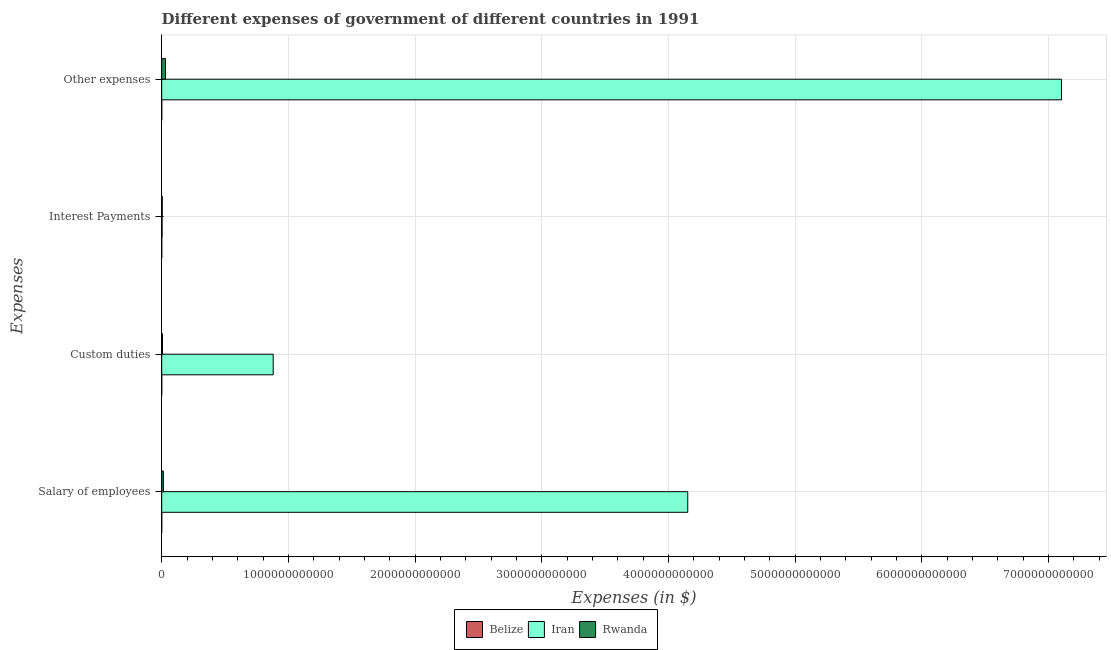Are the number of bars on each tick of the Y-axis equal?
Give a very brief answer. Yes. What is the label of the 3rd group of bars from the top?
Your answer should be compact. Custom duties. What is the amount spent on custom duties in Belize?
Provide a succinct answer. 1.06e+08. Across all countries, what is the maximum amount spent on other expenses?
Ensure brevity in your answer.  7.10e+12. Across all countries, what is the minimum amount spent on other expenses?
Offer a terse response. 1.51e+08. In which country was the amount spent on custom duties maximum?
Provide a succinct answer. Iran. In which country was the amount spent on custom duties minimum?
Your answer should be compact. Belize. What is the total amount spent on interest payments in the graph?
Make the answer very short. 7.30e+09. What is the difference between the amount spent on interest payments in Belize and that in Rwanda?
Ensure brevity in your answer.  -4.28e+09. What is the difference between the amount spent on custom duties in Belize and the amount spent on salary of employees in Iran?
Offer a terse response. -4.15e+12. What is the average amount spent on custom duties per country?
Offer a terse response. 2.95e+11. What is the difference between the amount spent on salary of employees and amount spent on custom duties in Iran?
Provide a short and direct response. 3.27e+12. What is the ratio of the amount spent on salary of employees in Belize to that in Rwanda?
Provide a succinct answer. 0.01. Is the amount spent on interest payments in Belize less than that in Iran?
Provide a short and direct response. Yes. Is the difference between the amount spent on salary of employees in Rwanda and Iran greater than the difference between the amount spent on other expenses in Rwanda and Iran?
Your response must be concise. Yes. What is the difference between the highest and the second highest amount spent on interest payments?
Your response must be concise. 1.29e+09. What is the difference between the highest and the lowest amount spent on other expenses?
Your answer should be very brief. 7.10e+12. In how many countries, is the amount spent on interest payments greater than the average amount spent on interest payments taken over all countries?
Offer a terse response. 2. Is it the case that in every country, the sum of the amount spent on interest payments and amount spent on salary of employees is greater than the sum of amount spent on other expenses and amount spent on custom duties?
Make the answer very short. No. What does the 2nd bar from the top in Interest Payments represents?
Make the answer very short. Iran. What does the 1st bar from the bottom in Interest Payments represents?
Your answer should be compact. Belize. Is it the case that in every country, the sum of the amount spent on salary of employees and amount spent on custom duties is greater than the amount spent on interest payments?
Your answer should be very brief. Yes. Are all the bars in the graph horizontal?
Your answer should be compact. Yes. How many countries are there in the graph?
Give a very brief answer. 3. What is the difference between two consecutive major ticks on the X-axis?
Offer a terse response. 1.00e+12. Are the values on the major ticks of X-axis written in scientific E-notation?
Provide a short and direct response. No. Does the graph contain grids?
Your answer should be compact. Yes. Where does the legend appear in the graph?
Offer a terse response. Bottom center. How are the legend labels stacked?
Your response must be concise. Horizontal. What is the title of the graph?
Keep it short and to the point. Different expenses of government of different countries in 1991. What is the label or title of the X-axis?
Provide a short and direct response. Expenses (in $). What is the label or title of the Y-axis?
Keep it short and to the point. Expenses. What is the Expenses (in $) of Belize in Salary of employees?
Provide a succinct answer. 9.61e+07. What is the Expenses (in $) in Iran in Salary of employees?
Your response must be concise. 4.15e+12. What is the Expenses (in $) in Rwanda in Salary of employees?
Ensure brevity in your answer.  1.33e+1. What is the Expenses (in $) in Belize in Custom duties?
Ensure brevity in your answer.  1.06e+08. What is the Expenses (in $) in Iran in Custom duties?
Provide a succinct answer. 8.80e+11. What is the Expenses (in $) in Rwanda in Custom duties?
Make the answer very short. 6.24e+09. What is the Expenses (in $) of Belize in Interest Payments?
Your answer should be compact. 1.08e+07. What is the Expenses (in $) of Iran in Interest Payments?
Ensure brevity in your answer.  3.00e+09. What is the Expenses (in $) in Rwanda in Interest Payments?
Give a very brief answer. 4.29e+09. What is the Expenses (in $) of Belize in Other expenses?
Provide a short and direct response. 1.51e+08. What is the Expenses (in $) in Iran in Other expenses?
Give a very brief answer. 7.10e+12. What is the Expenses (in $) in Rwanda in Other expenses?
Provide a short and direct response. 2.95e+1. Across all Expenses, what is the maximum Expenses (in $) in Belize?
Keep it short and to the point. 1.51e+08. Across all Expenses, what is the maximum Expenses (in $) of Iran?
Give a very brief answer. 7.10e+12. Across all Expenses, what is the maximum Expenses (in $) of Rwanda?
Your response must be concise. 2.95e+1. Across all Expenses, what is the minimum Expenses (in $) in Belize?
Your answer should be very brief. 1.08e+07. Across all Expenses, what is the minimum Expenses (in $) in Iran?
Offer a very short reply. 3.00e+09. Across all Expenses, what is the minimum Expenses (in $) in Rwanda?
Give a very brief answer. 4.29e+09. What is the total Expenses (in $) of Belize in the graph?
Your answer should be compact. 3.63e+08. What is the total Expenses (in $) of Iran in the graph?
Make the answer very short. 1.21e+13. What is the total Expenses (in $) of Rwanda in the graph?
Keep it short and to the point. 5.33e+1. What is the difference between the Expenses (in $) in Belize in Salary of employees and that in Custom duties?
Provide a succinct answer. -9.54e+06. What is the difference between the Expenses (in $) of Iran in Salary of employees and that in Custom duties?
Make the answer very short. 3.27e+12. What is the difference between the Expenses (in $) in Rwanda in Salary of employees and that in Custom duties?
Offer a terse response. 7.05e+09. What is the difference between the Expenses (in $) in Belize in Salary of employees and that in Interest Payments?
Make the answer very short. 8.53e+07. What is the difference between the Expenses (in $) in Iran in Salary of employees and that in Interest Payments?
Offer a very short reply. 4.15e+12. What is the difference between the Expenses (in $) in Rwanda in Salary of employees and that in Interest Payments?
Your response must be concise. 9.00e+09. What is the difference between the Expenses (in $) of Belize in Salary of employees and that in Other expenses?
Your response must be concise. -5.47e+07. What is the difference between the Expenses (in $) in Iran in Salary of employees and that in Other expenses?
Your answer should be compact. -2.95e+12. What is the difference between the Expenses (in $) in Rwanda in Salary of employees and that in Other expenses?
Offer a very short reply. -1.62e+1. What is the difference between the Expenses (in $) of Belize in Custom duties and that in Interest Payments?
Provide a succinct answer. 9.48e+07. What is the difference between the Expenses (in $) in Iran in Custom duties and that in Interest Payments?
Your answer should be compact. 8.77e+11. What is the difference between the Expenses (in $) of Rwanda in Custom duties and that in Interest Payments?
Make the answer very short. 1.95e+09. What is the difference between the Expenses (in $) in Belize in Custom duties and that in Other expenses?
Offer a terse response. -4.51e+07. What is the difference between the Expenses (in $) in Iran in Custom duties and that in Other expenses?
Your response must be concise. -6.22e+12. What is the difference between the Expenses (in $) of Rwanda in Custom duties and that in Other expenses?
Ensure brevity in your answer.  -2.33e+1. What is the difference between the Expenses (in $) of Belize in Interest Payments and that in Other expenses?
Offer a terse response. -1.40e+08. What is the difference between the Expenses (in $) of Iran in Interest Payments and that in Other expenses?
Offer a terse response. -7.10e+12. What is the difference between the Expenses (in $) of Rwanda in Interest Payments and that in Other expenses?
Provide a short and direct response. -2.52e+1. What is the difference between the Expenses (in $) of Belize in Salary of employees and the Expenses (in $) of Iran in Custom duties?
Offer a terse response. -8.80e+11. What is the difference between the Expenses (in $) of Belize in Salary of employees and the Expenses (in $) of Rwanda in Custom duties?
Your response must be concise. -6.15e+09. What is the difference between the Expenses (in $) of Iran in Salary of employees and the Expenses (in $) of Rwanda in Custom duties?
Give a very brief answer. 4.15e+12. What is the difference between the Expenses (in $) of Belize in Salary of employees and the Expenses (in $) of Iran in Interest Payments?
Provide a succinct answer. -2.90e+09. What is the difference between the Expenses (in $) in Belize in Salary of employees and the Expenses (in $) in Rwanda in Interest Payments?
Make the answer very short. -4.20e+09. What is the difference between the Expenses (in $) in Iran in Salary of employees and the Expenses (in $) in Rwanda in Interest Payments?
Provide a succinct answer. 4.15e+12. What is the difference between the Expenses (in $) in Belize in Salary of employees and the Expenses (in $) in Iran in Other expenses?
Offer a very short reply. -7.10e+12. What is the difference between the Expenses (in $) in Belize in Salary of employees and the Expenses (in $) in Rwanda in Other expenses?
Keep it short and to the point. -2.94e+1. What is the difference between the Expenses (in $) of Iran in Salary of employees and the Expenses (in $) of Rwanda in Other expenses?
Keep it short and to the point. 4.12e+12. What is the difference between the Expenses (in $) in Belize in Custom duties and the Expenses (in $) in Iran in Interest Payments?
Offer a terse response. -2.89e+09. What is the difference between the Expenses (in $) in Belize in Custom duties and the Expenses (in $) in Rwanda in Interest Payments?
Provide a succinct answer. -4.19e+09. What is the difference between the Expenses (in $) in Iran in Custom duties and the Expenses (in $) in Rwanda in Interest Payments?
Make the answer very short. 8.76e+11. What is the difference between the Expenses (in $) in Belize in Custom duties and the Expenses (in $) in Iran in Other expenses?
Provide a short and direct response. -7.10e+12. What is the difference between the Expenses (in $) in Belize in Custom duties and the Expenses (in $) in Rwanda in Other expenses?
Your response must be concise. -2.94e+1. What is the difference between the Expenses (in $) in Iran in Custom duties and the Expenses (in $) in Rwanda in Other expenses?
Offer a terse response. 8.50e+11. What is the difference between the Expenses (in $) of Belize in Interest Payments and the Expenses (in $) of Iran in Other expenses?
Offer a terse response. -7.10e+12. What is the difference between the Expenses (in $) in Belize in Interest Payments and the Expenses (in $) in Rwanda in Other expenses?
Offer a terse response. -2.95e+1. What is the difference between the Expenses (in $) of Iran in Interest Payments and the Expenses (in $) of Rwanda in Other expenses?
Keep it short and to the point. -2.65e+1. What is the average Expenses (in $) of Belize per Expenses?
Ensure brevity in your answer.  9.08e+07. What is the average Expenses (in $) in Iran per Expenses?
Provide a succinct answer. 3.03e+12. What is the average Expenses (in $) of Rwanda per Expenses?
Make the answer very short. 1.33e+1. What is the difference between the Expenses (in $) in Belize and Expenses (in $) in Iran in Salary of employees?
Your answer should be very brief. -4.15e+12. What is the difference between the Expenses (in $) in Belize and Expenses (in $) in Rwanda in Salary of employees?
Your response must be concise. -1.32e+1. What is the difference between the Expenses (in $) in Iran and Expenses (in $) in Rwanda in Salary of employees?
Ensure brevity in your answer.  4.14e+12. What is the difference between the Expenses (in $) of Belize and Expenses (in $) of Iran in Custom duties?
Keep it short and to the point. -8.80e+11. What is the difference between the Expenses (in $) in Belize and Expenses (in $) in Rwanda in Custom duties?
Provide a succinct answer. -6.14e+09. What is the difference between the Expenses (in $) of Iran and Expenses (in $) of Rwanda in Custom duties?
Your answer should be very brief. 8.74e+11. What is the difference between the Expenses (in $) of Belize and Expenses (in $) of Iran in Interest Payments?
Provide a short and direct response. -2.99e+09. What is the difference between the Expenses (in $) of Belize and Expenses (in $) of Rwanda in Interest Payments?
Provide a succinct answer. -4.28e+09. What is the difference between the Expenses (in $) of Iran and Expenses (in $) of Rwanda in Interest Payments?
Make the answer very short. -1.29e+09. What is the difference between the Expenses (in $) in Belize and Expenses (in $) in Iran in Other expenses?
Provide a succinct answer. -7.10e+12. What is the difference between the Expenses (in $) in Belize and Expenses (in $) in Rwanda in Other expenses?
Your response must be concise. -2.93e+1. What is the difference between the Expenses (in $) in Iran and Expenses (in $) in Rwanda in Other expenses?
Ensure brevity in your answer.  7.07e+12. What is the ratio of the Expenses (in $) of Belize in Salary of employees to that in Custom duties?
Ensure brevity in your answer.  0.91. What is the ratio of the Expenses (in $) in Iran in Salary of employees to that in Custom duties?
Your answer should be very brief. 4.72. What is the ratio of the Expenses (in $) in Rwanda in Salary of employees to that in Custom duties?
Offer a terse response. 2.13. What is the ratio of the Expenses (in $) in Belize in Salary of employees to that in Interest Payments?
Ensure brevity in your answer.  8.88. What is the ratio of the Expenses (in $) in Iran in Salary of employees to that in Interest Payments?
Keep it short and to the point. 1384. What is the ratio of the Expenses (in $) of Rwanda in Salary of employees to that in Interest Payments?
Keep it short and to the point. 3.1. What is the ratio of the Expenses (in $) in Belize in Salary of employees to that in Other expenses?
Provide a succinct answer. 0.64. What is the ratio of the Expenses (in $) in Iran in Salary of employees to that in Other expenses?
Keep it short and to the point. 0.58. What is the ratio of the Expenses (in $) of Rwanda in Salary of employees to that in Other expenses?
Your answer should be compact. 0.45. What is the ratio of the Expenses (in $) of Belize in Custom duties to that in Interest Payments?
Offer a very short reply. 9.76. What is the ratio of the Expenses (in $) in Iran in Custom duties to that in Interest Payments?
Keep it short and to the point. 293.33. What is the ratio of the Expenses (in $) of Rwanda in Custom duties to that in Interest Payments?
Give a very brief answer. 1.45. What is the ratio of the Expenses (in $) of Belize in Custom duties to that in Other expenses?
Give a very brief answer. 0.7. What is the ratio of the Expenses (in $) of Iran in Custom duties to that in Other expenses?
Your response must be concise. 0.12. What is the ratio of the Expenses (in $) in Rwanda in Custom duties to that in Other expenses?
Your answer should be very brief. 0.21. What is the ratio of the Expenses (in $) in Belize in Interest Payments to that in Other expenses?
Keep it short and to the point. 0.07. What is the ratio of the Expenses (in $) of Iran in Interest Payments to that in Other expenses?
Offer a very short reply. 0. What is the ratio of the Expenses (in $) of Rwanda in Interest Payments to that in Other expenses?
Ensure brevity in your answer.  0.15. What is the difference between the highest and the second highest Expenses (in $) of Belize?
Your response must be concise. 4.51e+07. What is the difference between the highest and the second highest Expenses (in $) of Iran?
Provide a short and direct response. 2.95e+12. What is the difference between the highest and the second highest Expenses (in $) in Rwanda?
Make the answer very short. 1.62e+1. What is the difference between the highest and the lowest Expenses (in $) of Belize?
Your answer should be very brief. 1.40e+08. What is the difference between the highest and the lowest Expenses (in $) of Iran?
Make the answer very short. 7.10e+12. What is the difference between the highest and the lowest Expenses (in $) of Rwanda?
Keep it short and to the point. 2.52e+1. 